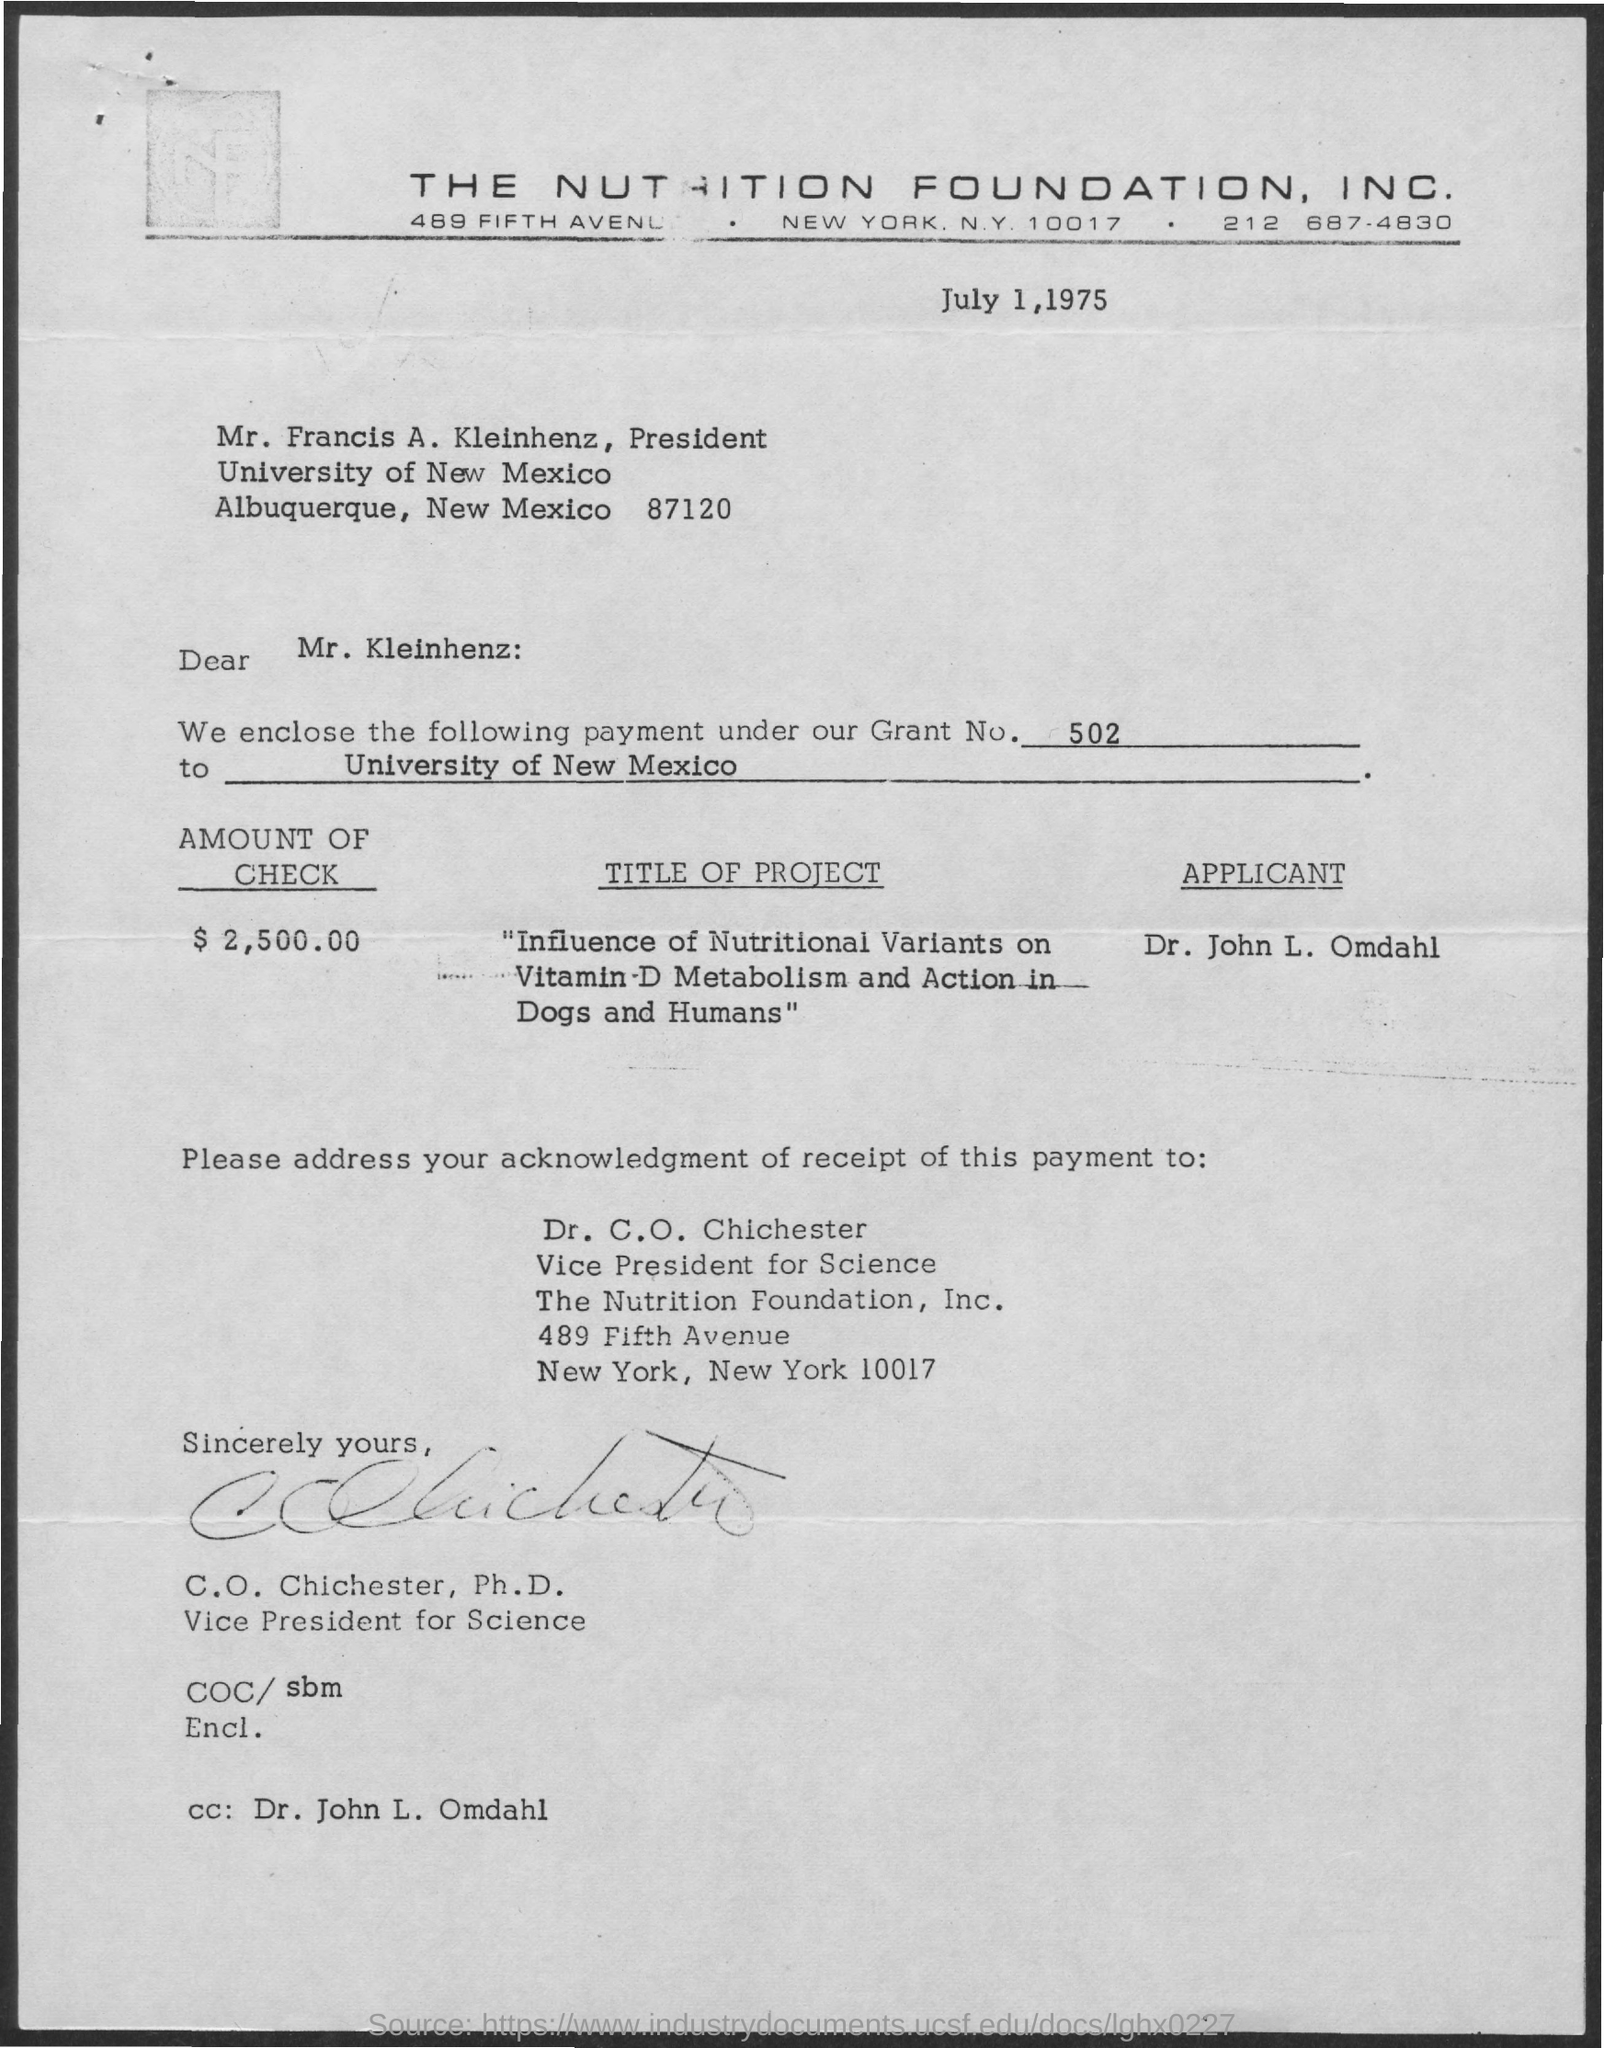What is the date mentioned in this document?
Keep it short and to the point. July 1, 1975. What is the Grant No. given in this document?
Your response must be concise. 502. What is the amount of check mentioned in this document
Make the answer very short. $2,500.00. Who is mentioned in the cc?
Give a very brief answer. Dr. John L. Omdahl. 